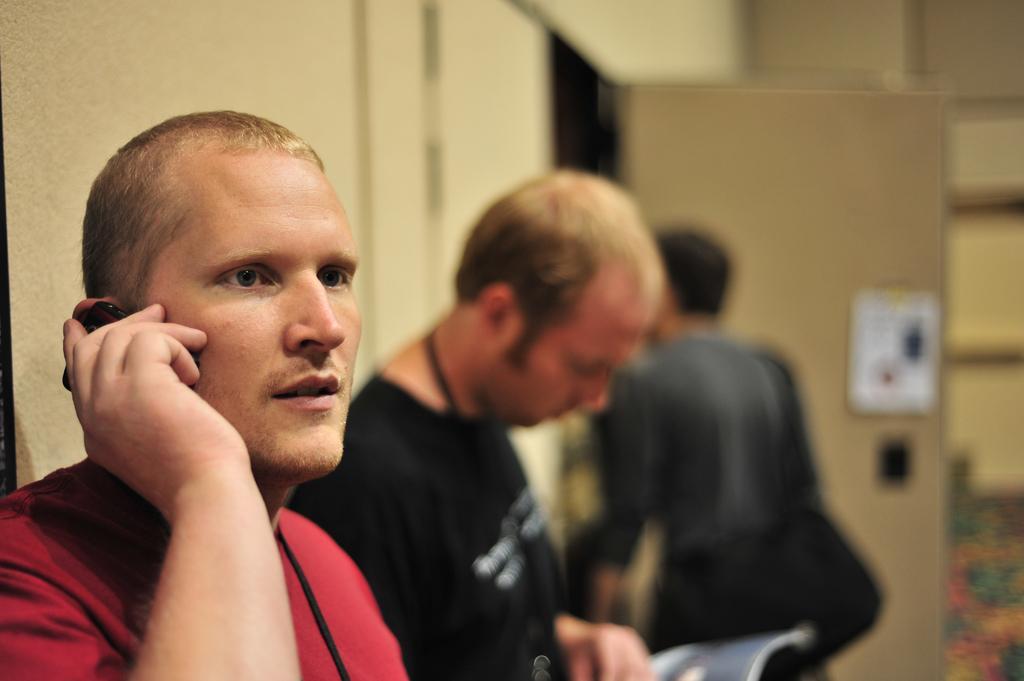What can be seen in the image? There are people standing in the image. What is located on the left side of the image? There is a wall on the left side of the image. Can you identify any openings in the wall? Yes, there is a door in the image. What type of berry is being used as a prop by the people in the image? There is no berry present in the image, and the people are not using any props. 